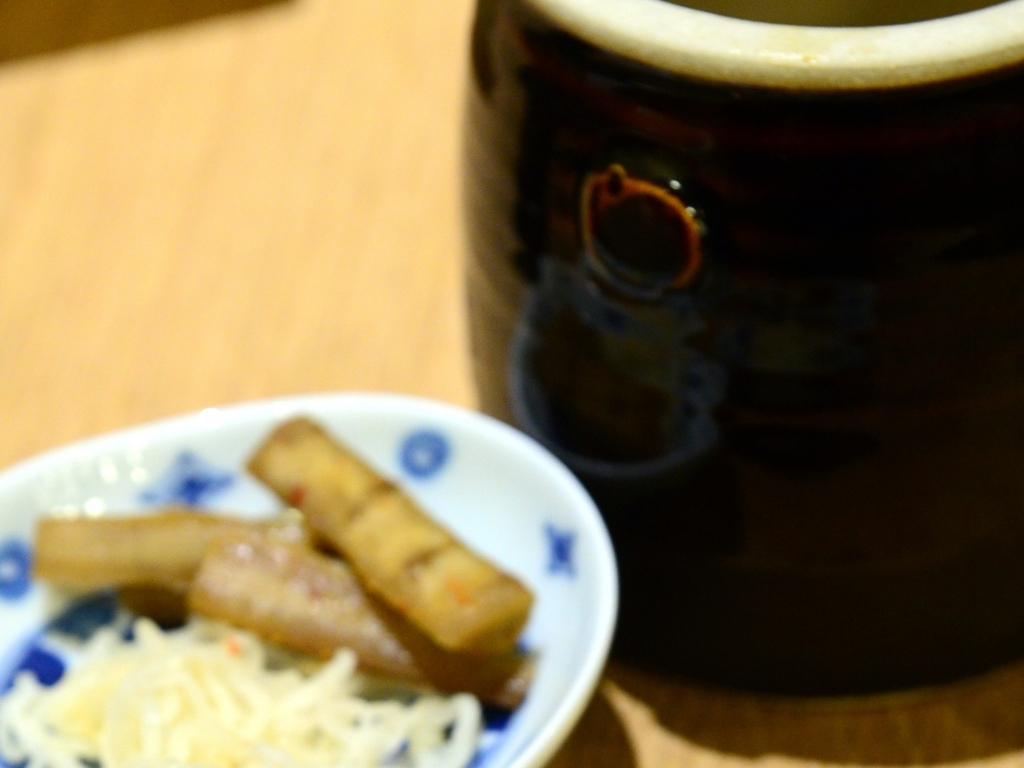How could this image be improved through editing or retaking the shot? To improve this image, it could be retaken with proper focus on the subject of interest, ensuring that the camera's focal point is correctly set. If desired, a shallow depth of field can be used to artistically blur the background while keeping the subject sharp. In terms of editing, sharpness can be slightly enhanced, although it is difficult to fully correct a misfocused image post-capture. Adding contrast and playing with color saturation might also help draw more attention to the main elements within the frame, even if not completely in focus. 